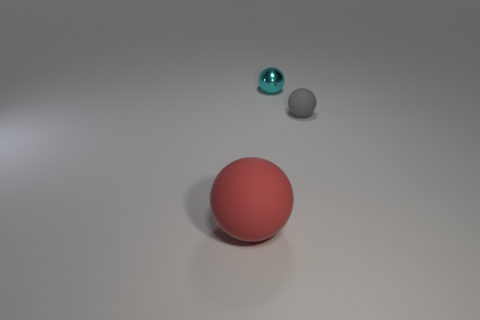What is the shape of the matte thing to the left of the tiny cyan metal thing?
Offer a very short reply. Sphere. How many red rubber objects are the same shape as the small cyan metal object?
Your answer should be very brief. 1. Does the rubber thing to the left of the gray ball have the same color as the rubber object that is right of the red matte thing?
Provide a short and direct response. No. What number of things are either large yellow metal things or tiny balls?
Your answer should be compact. 2. How many red spheres are made of the same material as the small gray ball?
Your response must be concise. 1. Is the number of large red rubber spheres less than the number of yellow balls?
Offer a terse response. No. Do the thing that is right of the cyan sphere and the big red sphere have the same material?
Give a very brief answer. Yes. How many balls are either cyan things or brown metallic objects?
Your answer should be compact. 1. What is the color of the object that is on the right side of the tiny sphere that is left of the small sphere that is in front of the small metallic sphere?
Provide a succinct answer. Gray. Is the number of red spheres behind the tiny cyan object less than the number of large red spheres?
Offer a terse response. Yes. 